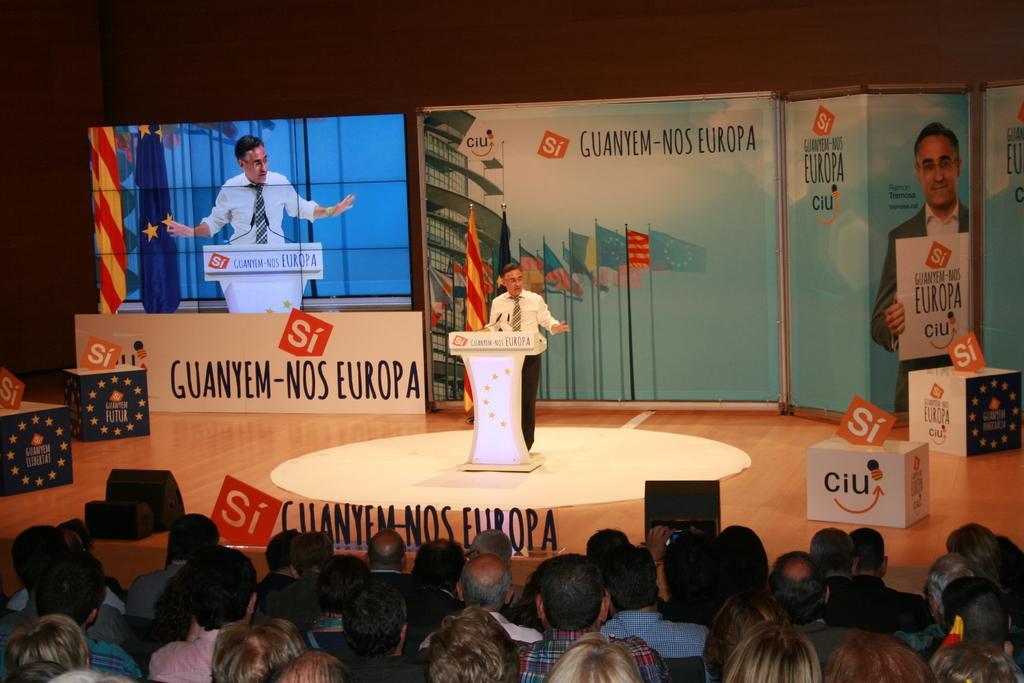How would you summarize this image in a sentence or two? In this image we can see a few people, some of them are sitting, one person is talking, in front of him there is a podium, and mice, behind to him there are boards with some text on them, there are flags, lights there are some boxes with text on them, there is a screen. 